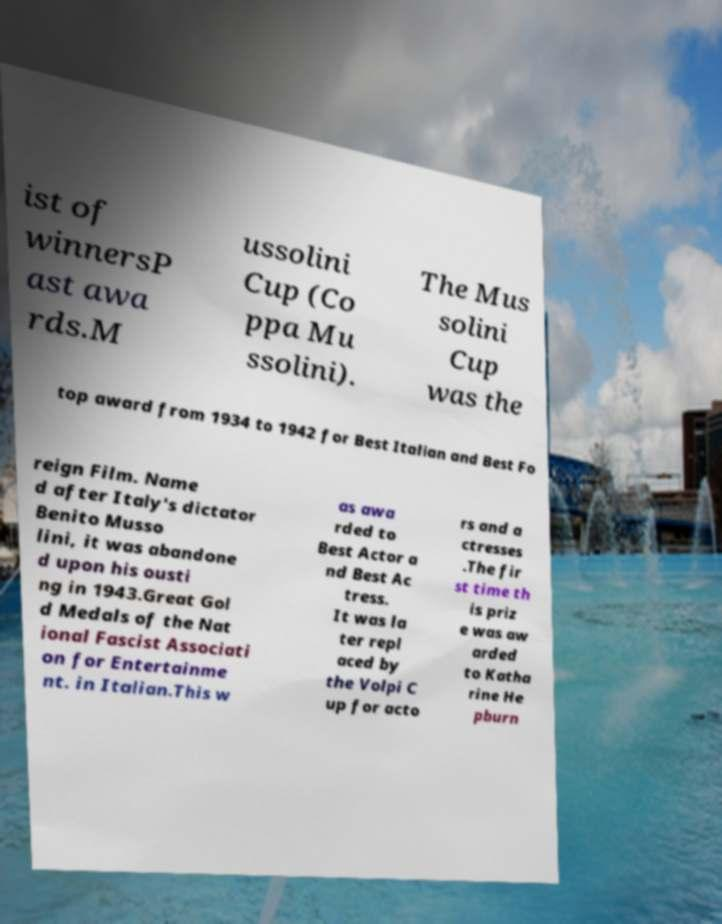What messages or text are displayed in this image? I need them in a readable, typed format. ist of winnersP ast awa rds.M ussolini Cup (Co ppa Mu ssolini). The Mus solini Cup was the top award from 1934 to 1942 for Best Italian and Best Fo reign Film. Name d after Italy's dictator Benito Musso lini, it was abandone d upon his ousti ng in 1943.Great Gol d Medals of the Nat ional Fascist Associati on for Entertainme nt. in Italian.This w as awa rded to Best Actor a nd Best Ac tress. It was la ter repl aced by the Volpi C up for acto rs and a ctresses .The fir st time th is priz e was aw arded to Katha rine He pburn 